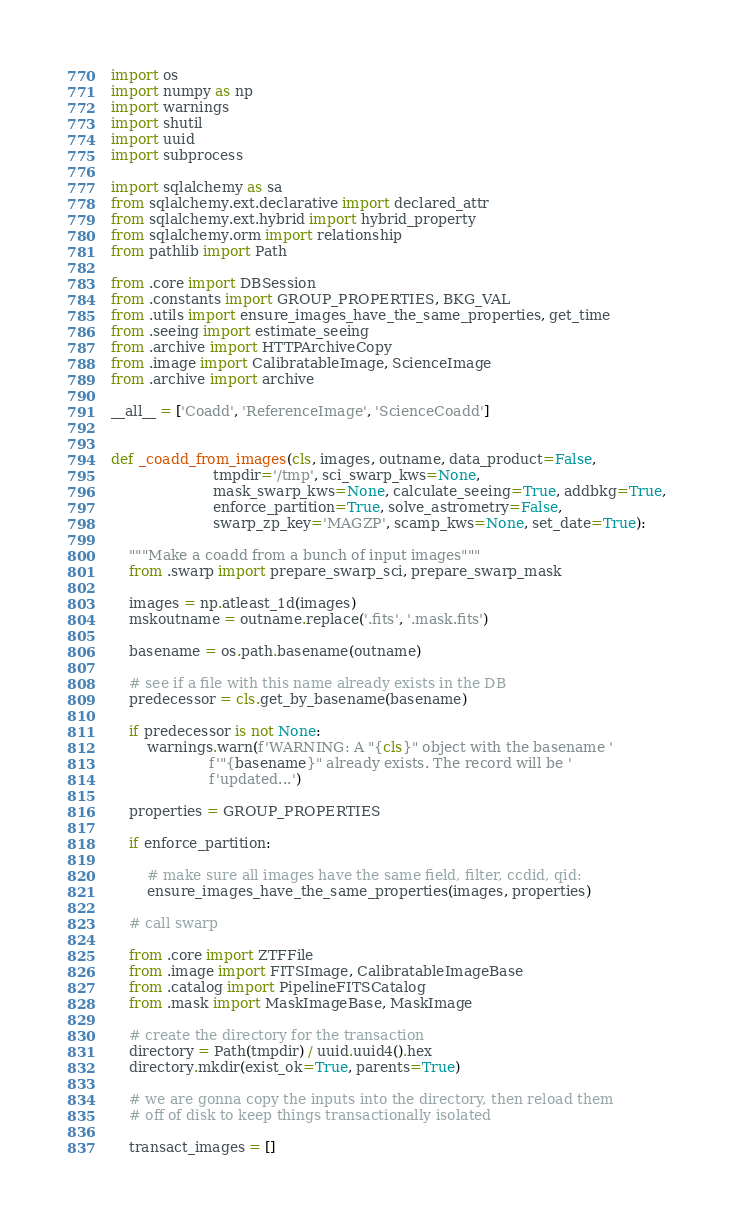<code> <loc_0><loc_0><loc_500><loc_500><_Python_>import os
import numpy as np
import warnings
import shutil
import uuid
import subprocess

import sqlalchemy as sa
from sqlalchemy.ext.declarative import declared_attr
from sqlalchemy.ext.hybrid import hybrid_property
from sqlalchemy.orm import relationship
from pathlib import Path

from .core import DBSession
from .constants import GROUP_PROPERTIES, BKG_VAL
from .utils import ensure_images_have_the_same_properties, get_time
from .seeing import estimate_seeing
from .archive import HTTPArchiveCopy
from .image import CalibratableImage, ScienceImage
from .archive import archive

__all__ = ['Coadd', 'ReferenceImage', 'ScienceCoadd']


def _coadd_from_images(cls, images, outname, data_product=False,
                       tmpdir='/tmp', sci_swarp_kws=None,
                       mask_swarp_kws=None, calculate_seeing=True, addbkg=True,
                       enforce_partition=True, solve_astrometry=False,
                       swarp_zp_key='MAGZP', scamp_kws=None, set_date=True):

    """Make a coadd from a bunch of input images"""
    from .swarp import prepare_swarp_sci, prepare_swarp_mask

    images = np.atleast_1d(images)
    mskoutname = outname.replace('.fits', '.mask.fits')

    basename = os.path.basename(outname)

    # see if a file with this name already exists in the DB
    predecessor = cls.get_by_basename(basename)

    if predecessor is not None:
        warnings.warn(f'WARNING: A "{cls}" object with the basename '
                      f'"{basename}" already exists. The record will be '
                      f'updated...')

    properties = GROUP_PROPERTIES

    if enforce_partition:

        # make sure all images have the same field, filter, ccdid, qid:
        ensure_images_have_the_same_properties(images, properties)

    # call swarp

    from .core import ZTFFile
    from .image import FITSImage, CalibratableImageBase
    from .catalog import PipelineFITSCatalog
    from .mask import MaskImageBase, MaskImage

    # create the directory for the transaction
    directory = Path(tmpdir) / uuid.uuid4().hex
    directory.mkdir(exist_ok=True, parents=True)

    # we are gonna copy the inputs into the directory, then reload them
    # off of disk to keep things transactionally isolated

    transact_images = []
</code> 